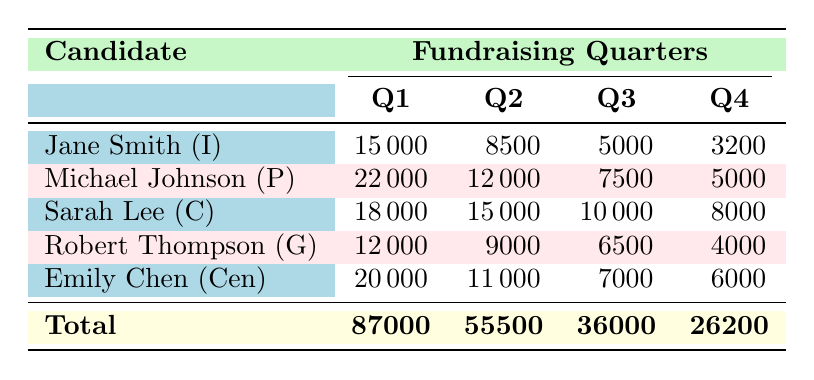What candidate raised the most in Q1? By looking at the Q1 column, the maximum amount is 22000 from Michael Johnson.
Answer: Michael Johnson What is the total amount raised by Sarah Lee across all quarters? To find the total for Sarah Lee, we add the amounts from each quarter: 18000 (Q1) + 15000 (Q2) + 10000 (Q3) + 8000 (Q4) = 51000.
Answer: 51000 Did any candidate raise funds from Environmental Groups? In the table, only Robert Thompson raised funds from Environmental Groups, indicated by a contribution of 9000 in Q2.
Answer: Yes Which quarter had the highest total fundraising across all candidates? The total amounts for each quarter are: Q1 = 87000, Q2 = 55500, Q3 = 36000, Q4 = 26200. The highest is Q1 with 87000.
Answer: Q1 How does the total amount raised in Q4 compare to Q2? The total for Q4 is 26200 and for Q2 is 55500. To compare, we see that 55500 is greater than 26200, confirming that Q2 raised more.
Answer: Q2 had more funds raised than Q4 